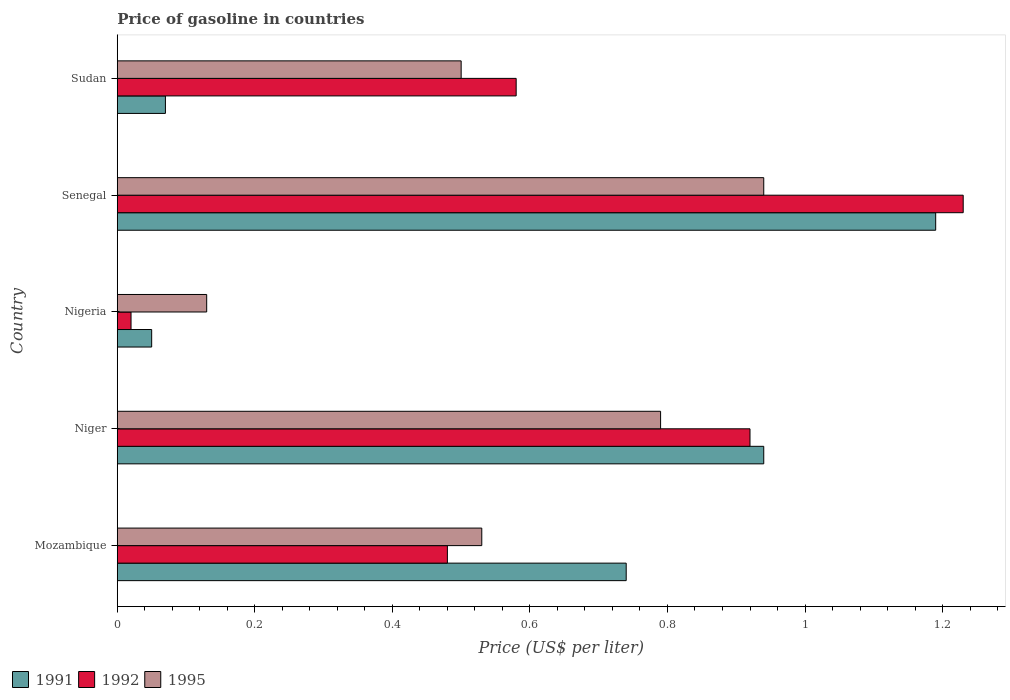How many groups of bars are there?
Offer a terse response. 5. Are the number of bars per tick equal to the number of legend labels?
Keep it short and to the point. Yes. Are the number of bars on each tick of the Y-axis equal?
Give a very brief answer. Yes. How many bars are there on the 3rd tick from the top?
Your response must be concise. 3. What is the label of the 5th group of bars from the top?
Give a very brief answer. Mozambique. In how many cases, is the number of bars for a given country not equal to the number of legend labels?
Your response must be concise. 0. What is the price of gasoline in 1991 in Mozambique?
Provide a short and direct response. 0.74. Across all countries, what is the maximum price of gasoline in 1995?
Offer a very short reply. 0.94. In which country was the price of gasoline in 1995 maximum?
Ensure brevity in your answer.  Senegal. In which country was the price of gasoline in 1992 minimum?
Provide a succinct answer. Nigeria. What is the total price of gasoline in 1992 in the graph?
Provide a short and direct response. 3.23. What is the difference between the price of gasoline in 1992 in Nigeria and that in Senegal?
Make the answer very short. -1.21. What is the difference between the price of gasoline in 1992 in Niger and the price of gasoline in 1995 in Senegal?
Make the answer very short. -0.02. What is the average price of gasoline in 1991 per country?
Offer a terse response. 0.6. What is the difference between the price of gasoline in 1991 and price of gasoline in 1995 in Mozambique?
Provide a succinct answer. 0.21. In how many countries, is the price of gasoline in 1992 greater than 1.08 US$?
Give a very brief answer. 1. What is the ratio of the price of gasoline in 1995 in Niger to that in Sudan?
Your answer should be very brief. 1.58. What is the difference between the highest and the second highest price of gasoline in 1991?
Make the answer very short. 0.25. What is the difference between the highest and the lowest price of gasoline in 1992?
Your answer should be very brief. 1.21. In how many countries, is the price of gasoline in 1992 greater than the average price of gasoline in 1992 taken over all countries?
Keep it short and to the point. 2. What does the 3rd bar from the bottom in Senegal represents?
Offer a terse response. 1995. Are all the bars in the graph horizontal?
Ensure brevity in your answer.  Yes. How many countries are there in the graph?
Provide a short and direct response. 5. What is the difference between two consecutive major ticks on the X-axis?
Your answer should be compact. 0.2. How many legend labels are there?
Offer a very short reply. 3. How are the legend labels stacked?
Your answer should be compact. Horizontal. What is the title of the graph?
Give a very brief answer. Price of gasoline in countries. What is the label or title of the X-axis?
Offer a very short reply. Price (US$ per liter). What is the label or title of the Y-axis?
Your answer should be compact. Country. What is the Price (US$ per liter) in 1991 in Mozambique?
Offer a very short reply. 0.74. What is the Price (US$ per liter) of 1992 in Mozambique?
Your response must be concise. 0.48. What is the Price (US$ per liter) of 1995 in Mozambique?
Provide a short and direct response. 0.53. What is the Price (US$ per liter) of 1991 in Niger?
Your answer should be compact. 0.94. What is the Price (US$ per liter) in 1995 in Niger?
Provide a short and direct response. 0.79. What is the Price (US$ per liter) in 1991 in Nigeria?
Your response must be concise. 0.05. What is the Price (US$ per liter) in 1995 in Nigeria?
Your answer should be very brief. 0.13. What is the Price (US$ per liter) in 1991 in Senegal?
Offer a terse response. 1.19. What is the Price (US$ per liter) of 1992 in Senegal?
Your answer should be compact. 1.23. What is the Price (US$ per liter) in 1991 in Sudan?
Provide a succinct answer. 0.07. What is the Price (US$ per liter) in 1992 in Sudan?
Give a very brief answer. 0.58. Across all countries, what is the maximum Price (US$ per liter) in 1991?
Keep it short and to the point. 1.19. Across all countries, what is the maximum Price (US$ per liter) in 1992?
Offer a terse response. 1.23. Across all countries, what is the minimum Price (US$ per liter) in 1992?
Offer a very short reply. 0.02. Across all countries, what is the minimum Price (US$ per liter) in 1995?
Offer a terse response. 0.13. What is the total Price (US$ per liter) of 1991 in the graph?
Your answer should be very brief. 2.99. What is the total Price (US$ per liter) in 1992 in the graph?
Your response must be concise. 3.23. What is the total Price (US$ per liter) of 1995 in the graph?
Make the answer very short. 2.89. What is the difference between the Price (US$ per liter) of 1992 in Mozambique and that in Niger?
Keep it short and to the point. -0.44. What is the difference between the Price (US$ per liter) in 1995 in Mozambique and that in Niger?
Offer a very short reply. -0.26. What is the difference between the Price (US$ per liter) of 1991 in Mozambique and that in Nigeria?
Offer a very short reply. 0.69. What is the difference between the Price (US$ per liter) of 1992 in Mozambique and that in Nigeria?
Provide a succinct answer. 0.46. What is the difference between the Price (US$ per liter) in 1995 in Mozambique and that in Nigeria?
Keep it short and to the point. 0.4. What is the difference between the Price (US$ per liter) in 1991 in Mozambique and that in Senegal?
Your response must be concise. -0.45. What is the difference between the Price (US$ per liter) in 1992 in Mozambique and that in Senegal?
Your answer should be compact. -0.75. What is the difference between the Price (US$ per liter) in 1995 in Mozambique and that in Senegal?
Offer a terse response. -0.41. What is the difference between the Price (US$ per liter) of 1991 in Mozambique and that in Sudan?
Provide a short and direct response. 0.67. What is the difference between the Price (US$ per liter) of 1992 in Mozambique and that in Sudan?
Keep it short and to the point. -0.1. What is the difference between the Price (US$ per liter) in 1995 in Mozambique and that in Sudan?
Your answer should be very brief. 0.03. What is the difference between the Price (US$ per liter) in 1991 in Niger and that in Nigeria?
Give a very brief answer. 0.89. What is the difference between the Price (US$ per liter) of 1995 in Niger and that in Nigeria?
Offer a very short reply. 0.66. What is the difference between the Price (US$ per liter) of 1991 in Niger and that in Senegal?
Provide a short and direct response. -0.25. What is the difference between the Price (US$ per liter) of 1992 in Niger and that in Senegal?
Provide a succinct answer. -0.31. What is the difference between the Price (US$ per liter) of 1995 in Niger and that in Senegal?
Offer a terse response. -0.15. What is the difference between the Price (US$ per liter) of 1991 in Niger and that in Sudan?
Offer a terse response. 0.87. What is the difference between the Price (US$ per liter) of 1992 in Niger and that in Sudan?
Provide a succinct answer. 0.34. What is the difference between the Price (US$ per liter) in 1995 in Niger and that in Sudan?
Offer a terse response. 0.29. What is the difference between the Price (US$ per liter) of 1991 in Nigeria and that in Senegal?
Offer a terse response. -1.14. What is the difference between the Price (US$ per liter) in 1992 in Nigeria and that in Senegal?
Your response must be concise. -1.21. What is the difference between the Price (US$ per liter) of 1995 in Nigeria and that in Senegal?
Offer a terse response. -0.81. What is the difference between the Price (US$ per liter) in 1991 in Nigeria and that in Sudan?
Keep it short and to the point. -0.02. What is the difference between the Price (US$ per liter) in 1992 in Nigeria and that in Sudan?
Your response must be concise. -0.56. What is the difference between the Price (US$ per liter) in 1995 in Nigeria and that in Sudan?
Offer a terse response. -0.37. What is the difference between the Price (US$ per liter) of 1991 in Senegal and that in Sudan?
Keep it short and to the point. 1.12. What is the difference between the Price (US$ per liter) in 1992 in Senegal and that in Sudan?
Make the answer very short. 0.65. What is the difference between the Price (US$ per liter) of 1995 in Senegal and that in Sudan?
Offer a terse response. 0.44. What is the difference between the Price (US$ per liter) of 1991 in Mozambique and the Price (US$ per liter) of 1992 in Niger?
Make the answer very short. -0.18. What is the difference between the Price (US$ per liter) of 1992 in Mozambique and the Price (US$ per liter) of 1995 in Niger?
Offer a terse response. -0.31. What is the difference between the Price (US$ per liter) of 1991 in Mozambique and the Price (US$ per liter) of 1992 in Nigeria?
Your response must be concise. 0.72. What is the difference between the Price (US$ per liter) of 1991 in Mozambique and the Price (US$ per liter) of 1995 in Nigeria?
Ensure brevity in your answer.  0.61. What is the difference between the Price (US$ per liter) of 1992 in Mozambique and the Price (US$ per liter) of 1995 in Nigeria?
Offer a terse response. 0.35. What is the difference between the Price (US$ per liter) in 1991 in Mozambique and the Price (US$ per liter) in 1992 in Senegal?
Make the answer very short. -0.49. What is the difference between the Price (US$ per liter) of 1992 in Mozambique and the Price (US$ per liter) of 1995 in Senegal?
Your answer should be compact. -0.46. What is the difference between the Price (US$ per liter) in 1991 in Mozambique and the Price (US$ per liter) in 1992 in Sudan?
Your response must be concise. 0.16. What is the difference between the Price (US$ per liter) of 1991 in Mozambique and the Price (US$ per liter) of 1995 in Sudan?
Ensure brevity in your answer.  0.24. What is the difference between the Price (US$ per liter) of 1992 in Mozambique and the Price (US$ per liter) of 1995 in Sudan?
Offer a terse response. -0.02. What is the difference between the Price (US$ per liter) in 1991 in Niger and the Price (US$ per liter) in 1995 in Nigeria?
Give a very brief answer. 0.81. What is the difference between the Price (US$ per liter) of 1992 in Niger and the Price (US$ per liter) of 1995 in Nigeria?
Offer a terse response. 0.79. What is the difference between the Price (US$ per liter) of 1991 in Niger and the Price (US$ per liter) of 1992 in Senegal?
Make the answer very short. -0.29. What is the difference between the Price (US$ per liter) of 1992 in Niger and the Price (US$ per liter) of 1995 in Senegal?
Your answer should be very brief. -0.02. What is the difference between the Price (US$ per liter) in 1991 in Niger and the Price (US$ per liter) in 1992 in Sudan?
Keep it short and to the point. 0.36. What is the difference between the Price (US$ per liter) in 1991 in Niger and the Price (US$ per liter) in 1995 in Sudan?
Provide a short and direct response. 0.44. What is the difference between the Price (US$ per liter) in 1992 in Niger and the Price (US$ per liter) in 1995 in Sudan?
Make the answer very short. 0.42. What is the difference between the Price (US$ per liter) in 1991 in Nigeria and the Price (US$ per liter) in 1992 in Senegal?
Your answer should be compact. -1.18. What is the difference between the Price (US$ per liter) in 1991 in Nigeria and the Price (US$ per liter) in 1995 in Senegal?
Keep it short and to the point. -0.89. What is the difference between the Price (US$ per liter) of 1992 in Nigeria and the Price (US$ per liter) of 1995 in Senegal?
Make the answer very short. -0.92. What is the difference between the Price (US$ per liter) in 1991 in Nigeria and the Price (US$ per liter) in 1992 in Sudan?
Offer a very short reply. -0.53. What is the difference between the Price (US$ per liter) in 1991 in Nigeria and the Price (US$ per liter) in 1995 in Sudan?
Provide a short and direct response. -0.45. What is the difference between the Price (US$ per liter) of 1992 in Nigeria and the Price (US$ per liter) of 1995 in Sudan?
Your response must be concise. -0.48. What is the difference between the Price (US$ per liter) of 1991 in Senegal and the Price (US$ per liter) of 1992 in Sudan?
Ensure brevity in your answer.  0.61. What is the difference between the Price (US$ per liter) in 1991 in Senegal and the Price (US$ per liter) in 1995 in Sudan?
Your answer should be very brief. 0.69. What is the difference between the Price (US$ per liter) in 1992 in Senegal and the Price (US$ per liter) in 1995 in Sudan?
Your answer should be very brief. 0.73. What is the average Price (US$ per liter) of 1991 per country?
Keep it short and to the point. 0.6. What is the average Price (US$ per liter) in 1992 per country?
Your answer should be very brief. 0.65. What is the average Price (US$ per liter) in 1995 per country?
Your answer should be compact. 0.58. What is the difference between the Price (US$ per liter) in 1991 and Price (US$ per liter) in 1992 in Mozambique?
Offer a very short reply. 0.26. What is the difference between the Price (US$ per liter) in 1991 and Price (US$ per liter) in 1995 in Mozambique?
Give a very brief answer. 0.21. What is the difference between the Price (US$ per liter) in 1992 and Price (US$ per liter) in 1995 in Mozambique?
Your response must be concise. -0.05. What is the difference between the Price (US$ per liter) in 1991 and Price (US$ per liter) in 1992 in Niger?
Make the answer very short. 0.02. What is the difference between the Price (US$ per liter) of 1992 and Price (US$ per liter) of 1995 in Niger?
Offer a terse response. 0.13. What is the difference between the Price (US$ per liter) of 1991 and Price (US$ per liter) of 1992 in Nigeria?
Your response must be concise. 0.03. What is the difference between the Price (US$ per liter) in 1991 and Price (US$ per liter) in 1995 in Nigeria?
Provide a short and direct response. -0.08. What is the difference between the Price (US$ per liter) of 1992 and Price (US$ per liter) of 1995 in Nigeria?
Give a very brief answer. -0.11. What is the difference between the Price (US$ per liter) in 1991 and Price (US$ per liter) in 1992 in Senegal?
Your response must be concise. -0.04. What is the difference between the Price (US$ per liter) of 1991 and Price (US$ per liter) of 1995 in Senegal?
Make the answer very short. 0.25. What is the difference between the Price (US$ per liter) in 1992 and Price (US$ per liter) in 1995 in Senegal?
Your answer should be very brief. 0.29. What is the difference between the Price (US$ per liter) of 1991 and Price (US$ per liter) of 1992 in Sudan?
Your answer should be compact. -0.51. What is the difference between the Price (US$ per liter) of 1991 and Price (US$ per liter) of 1995 in Sudan?
Your response must be concise. -0.43. What is the difference between the Price (US$ per liter) of 1992 and Price (US$ per liter) of 1995 in Sudan?
Keep it short and to the point. 0.08. What is the ratio of the Price (US$ per liter) of 1991 in Mozambique to that in Niger?
Offer a terse response. 0.79. What is the ratio of the Price (US$ per liter) in 1992 in Mozambique to that in Niger?
Make the answer very short. 0.52. What is the ratio of the Price (US$ per liter) of 1995 in Mozambique to that in Niger?
Offer a terse response. 0.67. What is the ratio of the Price (US$ per liter) in 1991 in Mozambique to that in Nigeria?
Offer a terse response. 14.8. What is the ratio of the Price (US$ per liter) of 1992 in Mozambique to that in Nigeria?
Your answer should be compact. 24. What is the ratio of the Price (US$ per liter) of 1995 in Mozambique to that in Nigeria?
Offer a terse response. 4.08. What is the ratio of the Price (US$ per liter) in 1991 in Mozambique to that in Senegal?
Give a very brief answer. 0.62. What is the ratio of the Price (US$ per liter) of 1992 in Mozambique to that in Senegal?
Provide a short and direct response. 0.39. What is the ratio of the Price (US$ per liter) in 1995 in Mozambique to that in Senegal?
Give a very brief answer. 0.56. What is the ratio of the Price (US$ per liter) in 1991 in Mozambique to that in Sudan?
Provide a succinct answer. 10.57. What is the ratio of the Price (US$ per liter) of 1992 in Mozambique to that in Sudan?
Offer a terse response. 0.83. What is the ratio of the Price (US$ per liter) of 1995 in Mozambique to that in Sudan?
Make the answer very short. 1.06. What is the ratio of the Price (US$ per liter) in 1992 in Niger to that in Nigeria?
Your answer should be very brief. 46. What is the ratio of the Price (US$ per liter) of 1995 in Niger to that in Nigeria?
Your answer should be very brief. 6.08. What is the ratio of the Price (US$ per liter) of 1991 in Niger to that in Senegal?
Offer a terse response. 0.79. What is the ratio of the Price (US$ per liter) of 1992 in Niger to that in Senegal?
Offer a terse response. 0.75. What is the ratio of the Price (US$ per liter) in 1995 in Niger to that in Senegal?
Offer a very short reply. 0.84. What is the ratio of the Price (US$ per liter) in 1991 in Niger to that in Sudan?
Make the answer very short. 13.43. What is the ratio of the Price (US$ per liter) in 1992 in Niger to that in Sudan?
Offer a terse response. 1.59. What is the ratio of the Price (US$ per liter) of 1995 in Niger to that in Sudan?
Make the answer very short. 1.58. What is the ratio of the Price (US$ per liter) of 1991 in Nigeria to that in Senegal?
Keep it short and to the point. 0.04. What is the ratio of the Price (US$ per liter) of 1992 in Nigeria to that in Senegal?
Your answer should be compact. 0.02. What is the ratio of the Price (US$ per liter) in 1995 in Nigeria to that in Senegal?
Provide a succinct answer. 0.14. What is the ratio of the Price (US$ per liter) of 1991 in Nigeria to that in Sudan?
Offer a terse response. 0.71. What is the ratio of the Price (US$ per liter) of 1992 in Nigeria to that in Sudan?
Offer a terse response. 0.03. What is the ratio of the Price (US$ per liter) in 1995 in Nigeria to that in Sudan?
Provide a succinct answer. 0.26. What is the ratio of the Price (US$ per liter) of 1992 in Senegal to that in Sudan?
Keep it short and to the point. 2.12. What is the ratio of the Price (US$ per liter) in 1995 in Senegal to that in Sudan?
Make the answer very short. 1.88. What is the difference between the highest and the second highest Price (US$ per liter) in 1992?
Your response must be concise. 0.31. What is the difference between the highest and the lowest Price (US$ per liter) in 1991?
Provide a short and direct response. 1.14. What is the difference between the highest and the lowest Price (US$ per liter) in 1992?
Your response must be concise. 1.21. What is the difference between the highest and the lowest Price (US$ per liter) in 1995?
Keep it short and to the point. 0.81. 